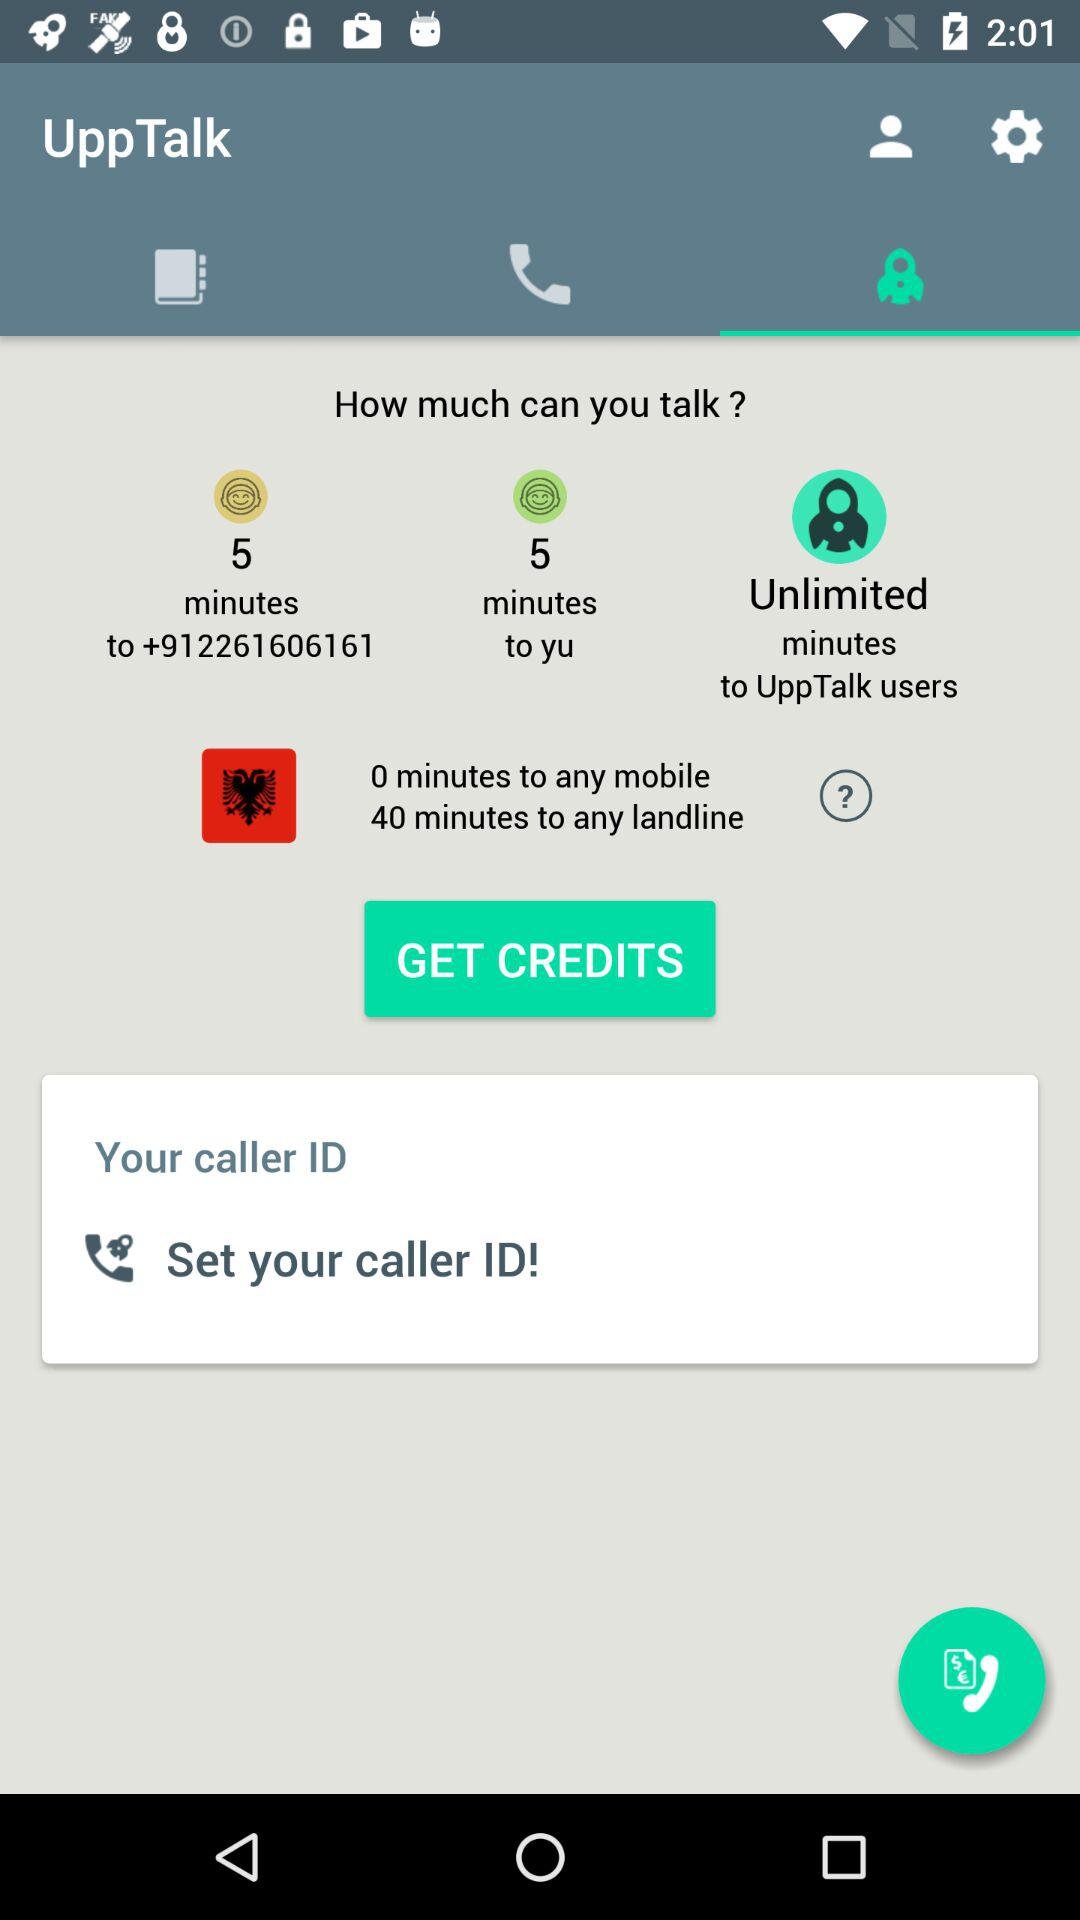How many minutes do I have to any UppTalk user?
Answer the question using a single word or phrase. Unlimited 